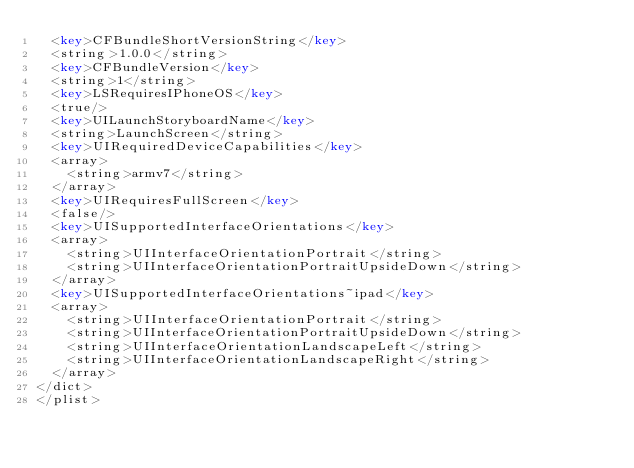Convert code to text. <code><loc_0><loc_0><loc_500><loc_500><_XML_>	<key>CFBundleShortVersionString</key>
	<string>1.0.0</string>
	<key>CFBundleVersion</key>
	<string>1</string>
	<key>LSRequiresIPhoneOS</key>
	<true/>
	<key>UILaunchStoryboardName</key>
	<string>LaunchScreen</string>
	<key>UIRequiredDeviceCapabilities</key>
	<array>
		<string>armv7</string>
	</array>
	<key>UIRequiresFullScreen</key>
	<false/>
	<key>UISupportedInterfaceOrientations</key>
	<array>
		<string>UIInterfaceOrientationPortrait</string>
		<string>UIInterfaceOrientationPortraitUpsideDown</string>
	</array>
	<key>UISupportedInterfaceOrientations~ipad</key>
	<array>
		<string>UIInterfaceOrientationPortrait</string>
		<string>UIInterfaceOrientationPortraitUpsideDown</string>
		<string>UIInterfaceOrientationLandscapeLeft</string>
		<string>UIInterfaceOrientationLandscapeRight</string>
	</array>
</dict>
</plist>
</code> 